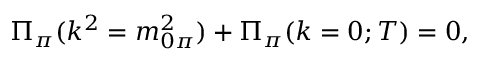Convert formula to latex. <formula><loc_0><loc_0><loc_500><loc_500>{ \Pi } _ { \pi } ( k ^ { 2 } = m _ { 0 \pi } ^ { 2 } ) + { \Pi } _ { \pi } ( k = 0 ; T ) = 0 ,</formula> 